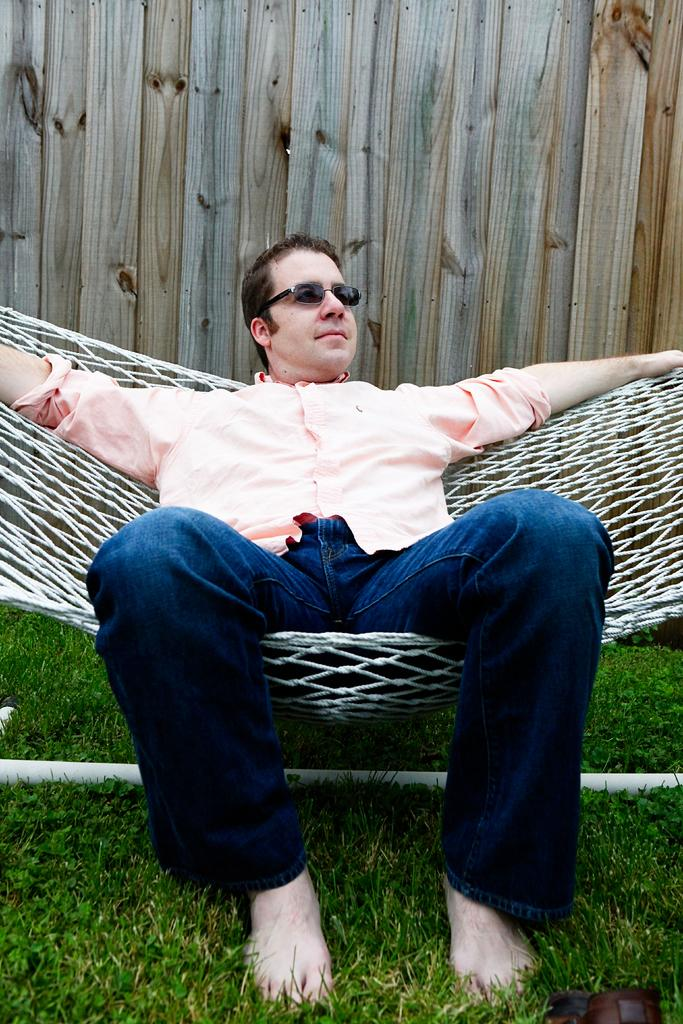What is the main subject of the image? There is a person in the image. What is the person wearing on their upper body? The person is wearing a pink shirt. What is the person wearing on their lower body? The person is wearing blue jeans. What is the person sitting on in the image? The person is sitting on a white-colored net. What type of vegetation can be seen in the image? There is grass visible in the image. What is the color and material of the pole in the image? There is a white-colored metal pole in the image. What type of wall is present in the image? There is a wooden wall in the image. What type of sweater is the person wearing in the image? The person is not wearing a sweater in the image; they are wearing a pink shirt. How many leaves are visible on the wooden wall in the image? There are no leaves visible on the wooden wall in the image. 